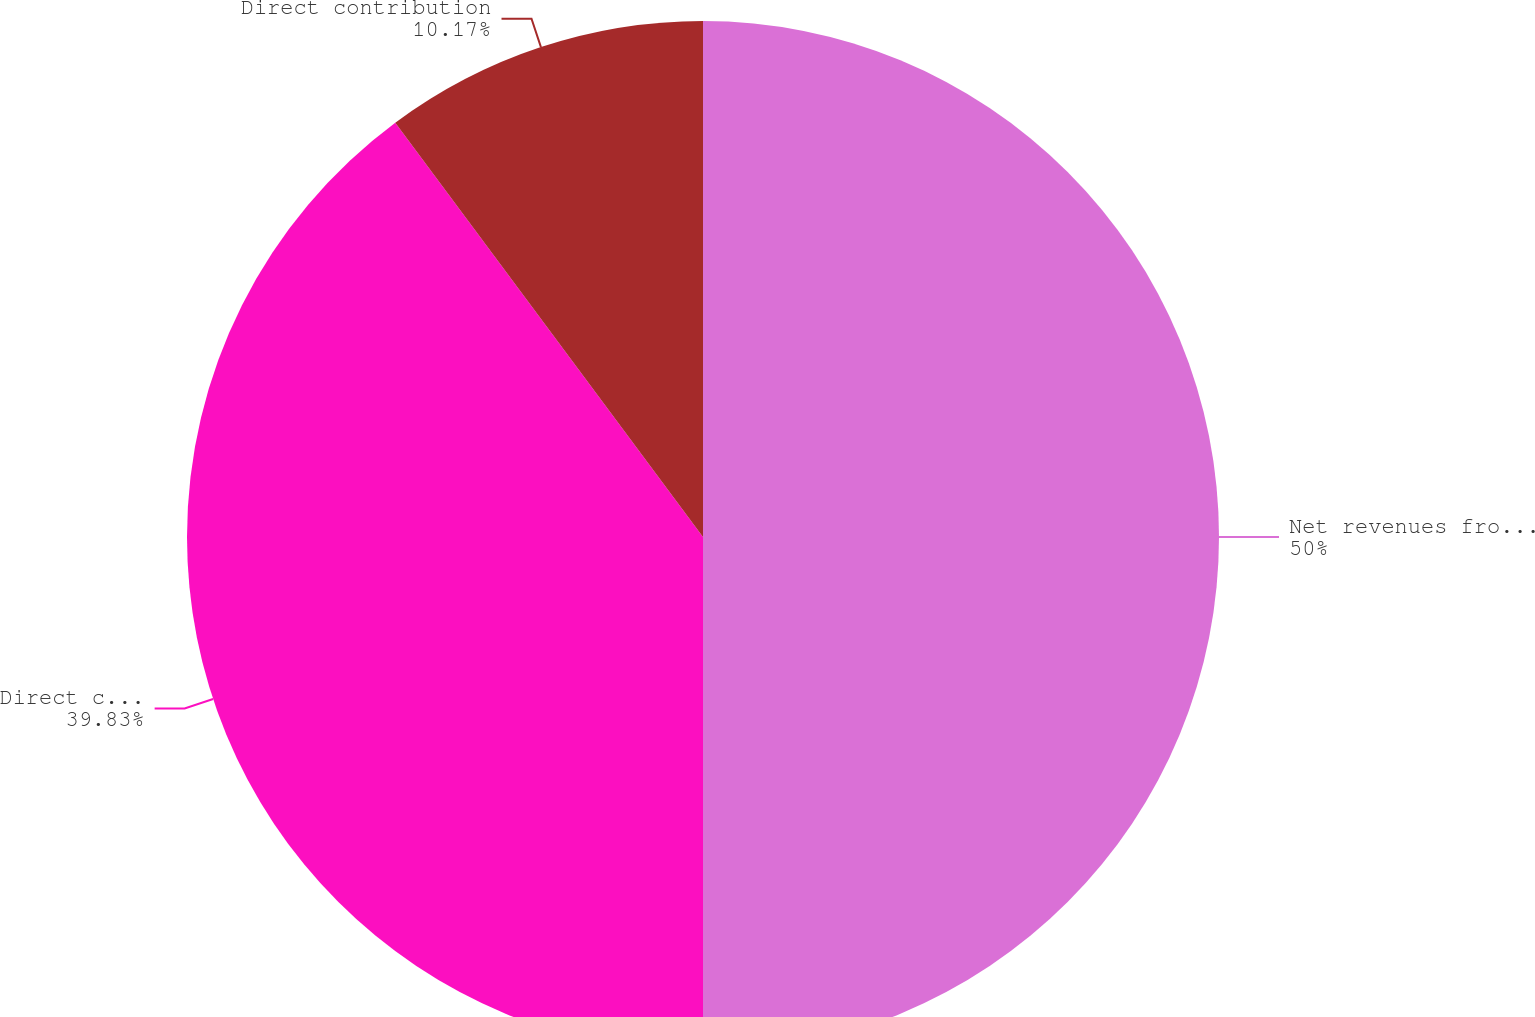<chart> <loc_0><loc_0><loc_500><loc_500><pie_chart><fcel>Net revenues from external<fcel>Direct costs<fcel>Direct contribution<nl><fcel>50.0%<fcel>39.83%<fcel>10.17%<nl></chart> 